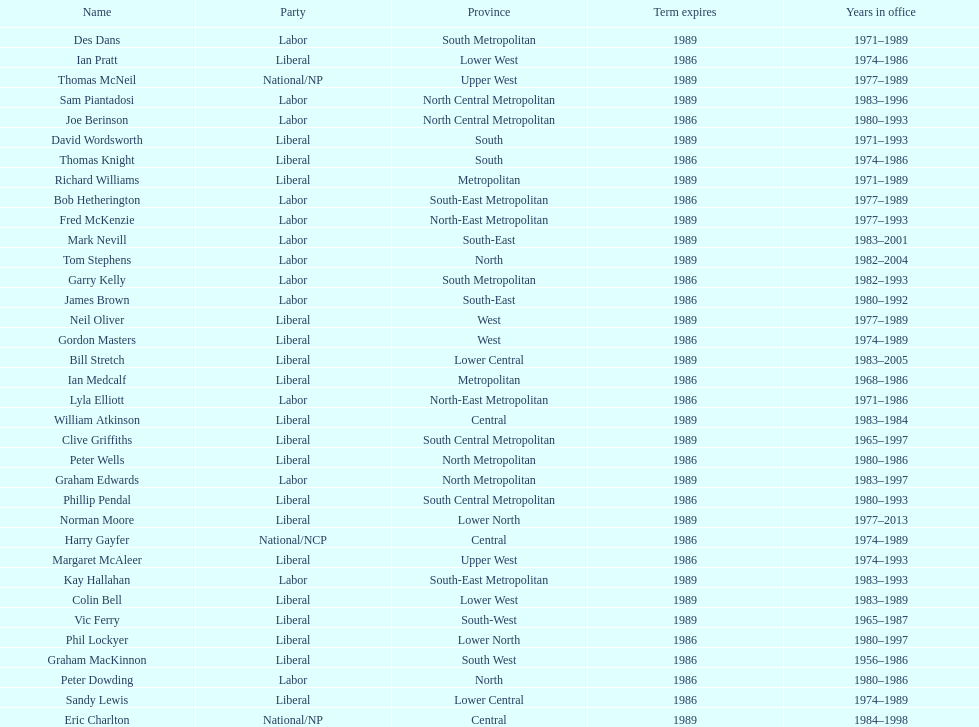Who experienced the briefest tenure in office? William Atkinson. 